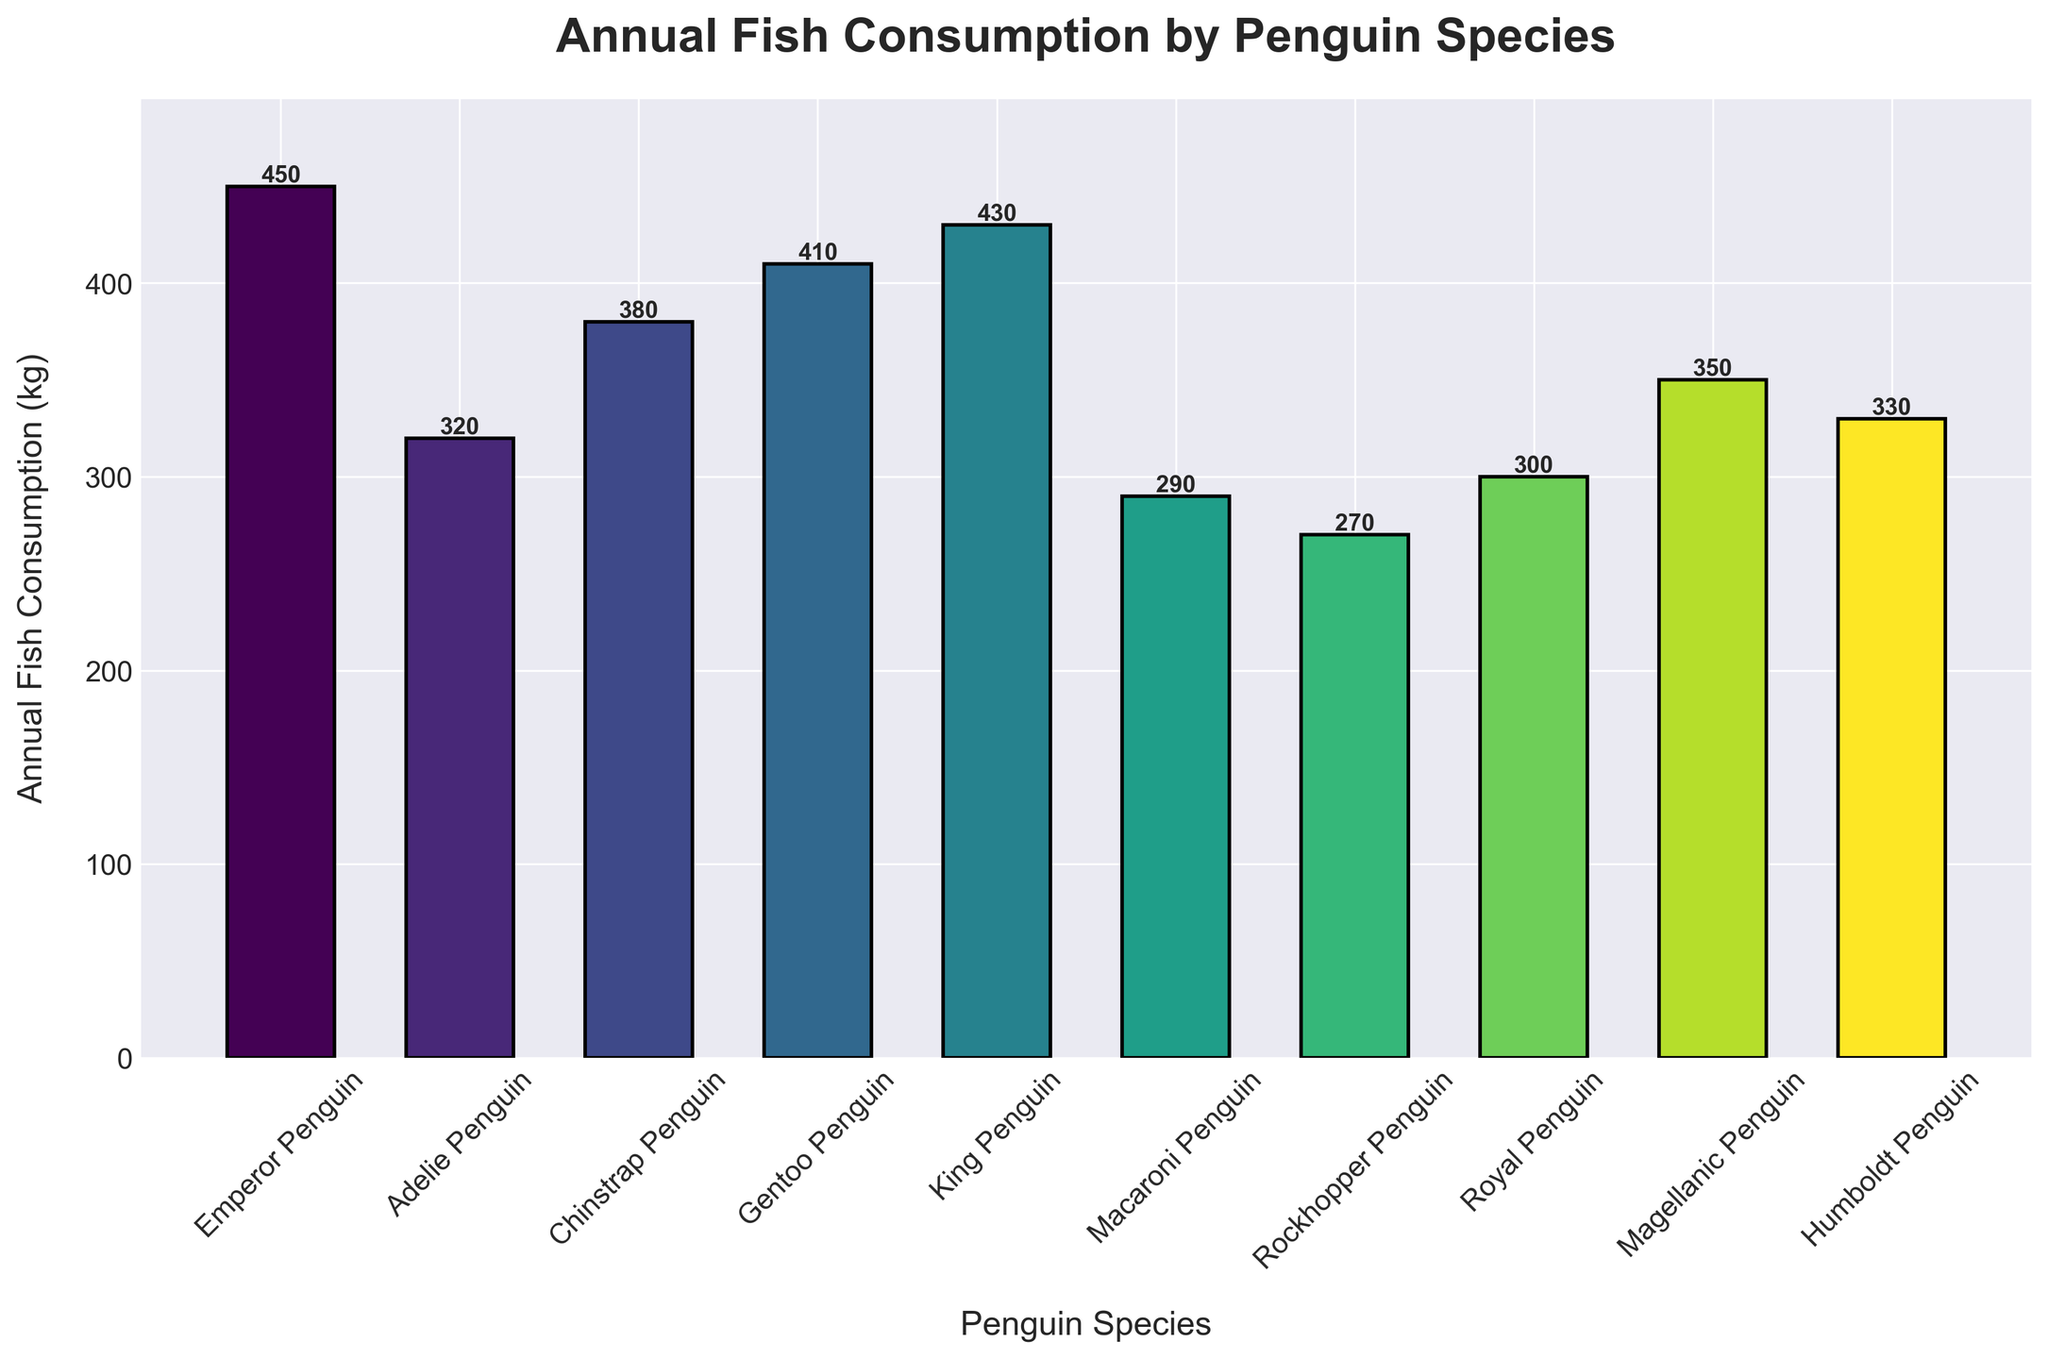Which penguin species consumes the most fish annually? By observing the heights of the bars, the bar representing the Emperor Penguin is the tallest. This indicates that the Emperor Penguin has the highest annual fish consumption.
Answer: Emperor Penguin Which two penguin species have the closest annual fish consumption rates? By comparing the heights of the bars, the bar heights of the King Penguin and the Gentoo Penguin look similar. Their consumption values (430 kg and 410 kg, respectively) are close.
Answer: King Penguin and Gentoo Penguin What is the total annual fish consumption of the top three species? The top three species by fish consumption are the Emperor Penguin (450 kg), the King Penguin (430 kg), and the Gentoo Penguin (410 kg). Adding these values gives: 450 + 430 + 410 = 1290 kg.
Answer: 1290 kg What is the difference in fish consumption between the species with the highest and lowest consumption? The species with the highest consumption is the Emperor Penguin (450 kg), and the species with the lowest consumption is the Rockhopper Penguin (270 kg). The difference is: 450 - 270 = 180 kg.
Answer: 180 kg How much more fish does the Chinstrap Penguin consume annually compared to the Macaroni Penguin? The Chinstrap Penguin consumes 380 kg, and the Macaroni Penguin consumes 290 kg. The difference is: 380 - 290 = 90 kg.
Answer: 90 kg Which penguin species have an annual fish consumption of more than 400 kg? From the bars, the species with values over 400 kg are the Emperor Penguin (450 kg), King Penguin (430 kg), and Gentoo Penguin (410 kg).
Answer: Emperor Penguin, King Penguin, and Gentoo Penguin What is the average annual fish consumption across all species? Summing the consumption values of all species (450 + 320 + 380 + 410 + 430 + 290 + 270 + 300 + 350 + 330) gives 3530 kg. Dividing by the number of species (10) gives: 3530 / 10 = 353 kg.
Answer: 353 kg Are there any species with equal annual fish consumption rates? By comparing all the bars, none of the bars have the exact same height, indicating no two species have equal annual fish consumption rates.
Answer: No What is the annual fish consumption of the Adelie Penguin as a percentage of the Emperor Penguin's consumption? The Adelie Penguin consumes 320 kg, and the Emperor Penguin consumes 450 kg. The percentage is calculated as: (320 / 450) * 100 ≈ 71.1%.
Answer: 71.1% Which species shows a higher annual fish consumption: the Humboldt Penguin or the Magellanic Penguin? Comparing the bar heights, the Magellanic Penguin (350 kg) consumes more than the Humboldt Penguin (330 kg).
Answer: Magellanic Penguin 